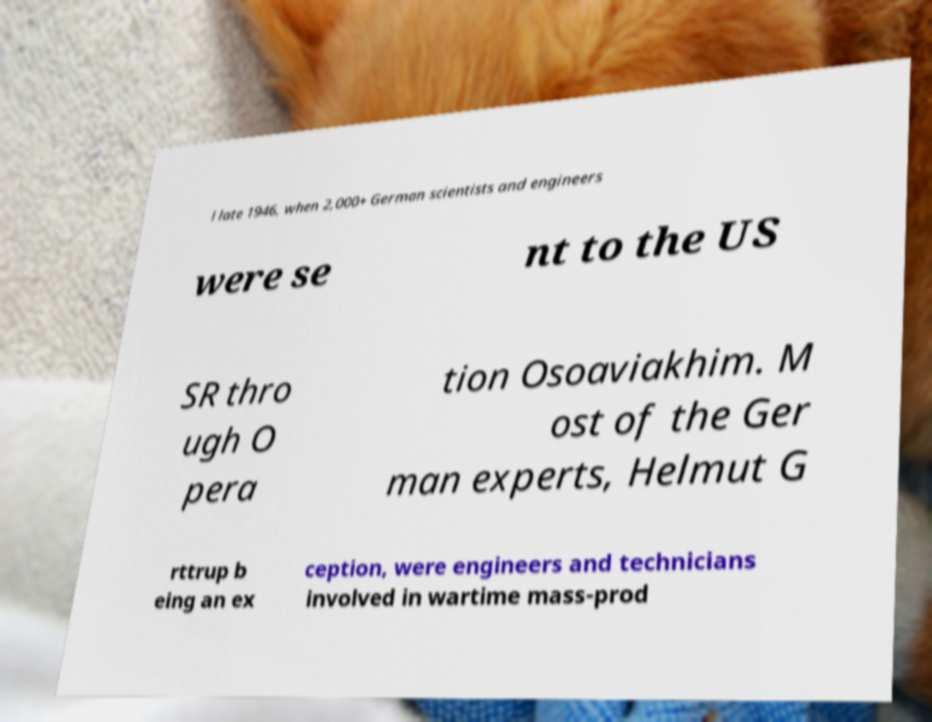There's text embedded in this image that I need extracted. Can you transcribe it verbatim? l late 1946, when 2,000+ German scientists and engineers were se nt to the US SR thro ugh O pera tion Osoaviakhim. M ost of the Ger man experts, Helmut G rttrup b eing an ex ception, were engineers and technicians involved in wartime mass-prod 